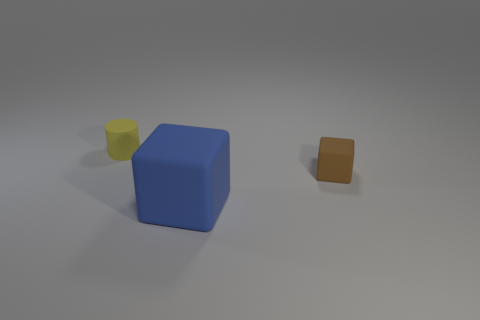Subtract all blocks. How many objects are left? 1 Subtract 1 cylinders. How many cylinders are left? 0 Add 2 blue rubber cubes. How many objects exist? 5 Subtract 0 gray blocks. How many objects are left? 3 Subtract all gray cubes. Subtract all green cylinders. How many cubes are left? 2 Subtract all yellow cylinders. How many brown blocks are left? 1 Subtract all green things. Subtract all big things. How many objects are left? 2 Add 2 small yellow matte objects. How many small yellow matte objects are left? 3 Add 3 large cyan things. How many large cyan things exist? 3 